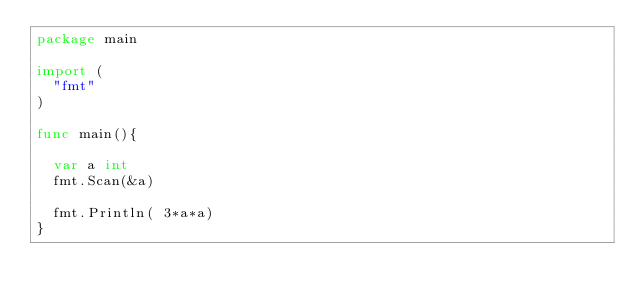Convert code to text. <code><loc_0><loc_0><loc_500><loc_500><_Go_>package main

import (
  "fmt"
)

func main(){
  
  var a int
  fmt.Scan(&a)
  
  fmt.Println( 3*a*a)
}</code> 